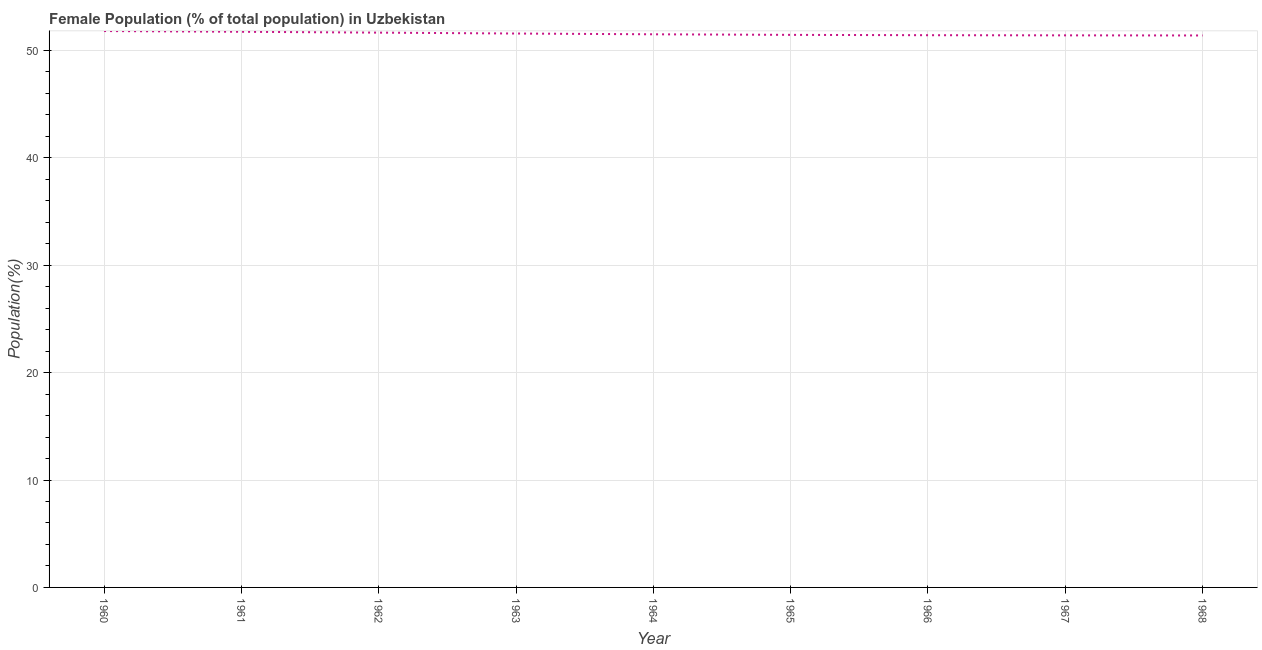What is the female population in 1961?
Your response must be concise. 51.73. Across all years, what is the maximum female population?
Ensure brevity in your answer.  51.79. Across all years, what is the minimum female population?
Keep it short and to the point. 51.38. In which year was the female population minimum?
Provide a succinct answer. 1968. What is the sum of the female population?
Provide a short and direct response. 463.84. What is the difference between the female population in 1967 and 1968?
Provide a short and direct response. 0.01. What is the average female population per year?
Your answer should be compact. 51.54. What is the median female population?
Ensure brevity in your answer.  51.49. In how many years, is the female population greater than 28 %?
Provide a succinct answer. 9. What is the ratio of the female population in 1964 to that in 1965?
Offer a very short reply. 1. Is the female population in 1960 less than that in 1961?
Give a very brief answer. No. Is the difference between the female population in 1965 and 1968 greater than the difference between any two years?
Keep it short and to the point. No. What is the difference between the highest and the second highest female population?
Keep it short and to the point. 0.07. Is the sum of the female population in 1963 and 1966 greater than the maximum female population across all years?
Keep it short and to the point. Yes. What is the difference between the highest and the lowest female population?
Provide a short and direct response. 0.41. In how many years, is the female population greater than the average female population taken over all years?
Provide a succinct answer. 4. Does the female population monotonically increase over the years?
Ensure brevity in your answer.  No. How many lines are there?
Keep it short and to the point. 1. What is the difference between two consecutive major ticks on the Y-axis?
Give a very brief answer. 10. Are the values on the major ticks of Y-axis written in scientific E-notation?
Ensure brevity in your answer.  No. Does the graph contain any zero values?
Give a very brief answer. No. Does the graph contain grids?
Your response must be concise. Yes. What is the title of the graph?
Keep it short and to the point. Female Population (% of total population) in Uzbekistan. What is the label or title of the Y-axis?
Offer a very short reply. Population(%). What is the Population(%) in 1960?
Make the answer very short. 51.79. What is the Population(%) of 1961?
Ensure brevity in your answer.  51.73. What is the Population(%) of 1962?
Your answer should be compact. 51.65. What is the Population(%) in 1963?
Your answer should be compact. 51.56. What is the Population(%) of 1964?
Make the answer very short. 51.49. What is the Population(%) in 1965?
Make the answer very short. 51.44. What is the Population(%) in 1966?
Provide a succinct answer. 51.41. What is the Population(%) in 1967?
Give a very brief answer. 51.39. What is the Population(%) in 1968?
Provide a short and direct response. 51.38. What is the difference between the Population(%) in 1960 and 1961?
Your response must be concise. 0.07. What is the difference between the Population(%) in 1960 and 1962?
Ensure brevity in your answer.  0.15. What is the difference between the Population(%) in 1960 and 1963?
Your answer should be very brief. 0.23. What is the difference between the Population(%) in 1960 and 1964?
Your answer should be very brief. 0.3. What is the difference between the Population(%) in 1960 and 1965?
Make the answer very short. 0.36. What is the difference between the Population(%) in 1960 and 1966?
Keep it short and to the point. 0.39. What is the difference between the Population(%) in 1960 and 1967?
Keep it short and to the point. 0.4. What is the difference between the Population(%) in 1960 and 1968?
Provide a succinct answer. 0.41. What is the difference between the Population(%) in 1961 and 1962?
Ensure brevity in your answer.  0.08. What is the difference between the Population(%) in 1961 and 1963?
Your answer should be compact. 0.16. What is the difference between the Population(%) in 1961 and 1964?
Give a very brief answer. 0.23. What is the difference between the Population(%) in 1961 and 1965?
Ensure brevity in your answer.  0.29. What is the difference between the Population(%) in 1961 and 1966?
Make the answer very short. 0.32. What is the difference between the Population(%) in 1961 and 1967?
Give a very brief answer. 0.33. What is the difference between the Population(%) in 1961 and 1968?
Your response must be concise. 0.34. What is the difference between the Population(%) in 1962 and 1963?
Your answer should be very brief. 0.08. What is the difference between the Population(%) in 1962 and 1964?
Keep it short and to the point. 0.15. What is the difference between the Population(%) in 1962 and 1965?
Provide a succinct answer. 0.21. What is the difference between the Population(%) in 1962 and 1966?
Your answer should be compact. 0.24. What is the difference between the Population(%) in 1962 and 1967?
Offer a very short reply. 0.25. What is the difference between the Population(%) in 1962 and 1968?
Make the answer very short. 0.26. What is the difference between the Population(%) in 1963 and 1964?
Offer a very short reply. 0.07. What is the difference between the Population(%) in 1963 and 1965?
Ensure brevity in your answer.  0.12. What is the difference between the Population(%) in 1963 and 1966?
Offer a terse response. 0.16. What is the difference between the Population(%) in 1963 and 1967?
Keep it short and to the point. 0.17. What is the difference between the Population(%) in 1963 and 1968?
Make the answer very short. 0.18. What is the difference between the Population(%) in 1964 and 1965?
Make the answer very short. 0.05. What is the difference between the Population(%) in 1964 and 1966?
Your answer should be very brief. 0.08. What is the difference between the Population(%) in 1964 and 1967?
Keep it short and to the point. 0.1. What is the difference between the Population(%) in 1964 and 1968?
Offer a terse response. 0.11. What is the difference between the Population(%) in 1965 and 1966?
Give a very brief answer. 0.03. What is the difference between the Population(%) in 1965 and 1967?
Your answer should be very brief. 0.04. What is the difference between the Population(%) in 1965 and 1968?
Offer a very short reply. 0.06. What is the difference between the Population(%) in 1966 and 1967?
Give a very brief answer. 0.01. What is the difference between the Population(%) in 1966 and 1968?
Keep it short and to the point. 0.02. What is the difference between the Population(%) in 1967 and 1968?
Make the answer very short. 0.01. What is the ratio of the Population(%) in 1960 to that in 1961?
Provide a short and direct response. 1. What is the ratio of the Population(%) in 1960 to that in 1963?
Give a very brief answer. 1. What is the ratio of the Population(%) in 1960 to that in 1966?
Offer a very short reply. 1.01. What is the ratio of the Population(%) in 1960 to that in 1967?
Provide a succinct answer. 1.01. What is the ratio of the Population(%) in 1960 to that in 1968?
Keep it short and to the point. 1.01. What is the ratio of the Population(%) in 1961 to that in 1963?
Offer a terse response. 1. What is the ratio of the Population(%) in 1961 to that in 1964?
Make the answer very short. 1. What is the ratio of the Population(%) in 1961 to that in 1965?
Keep it short and to the point. 1.01. What is the ratio of the Population(%) in 1961 to that in 1966?
Your response must be concise. 1.01. What is the ratio of the Population(%) in 1963 to that in 1964?
Make the answer very short. 1. What is the ratio of the Population(%) in 1963 to that in 1965?
Provide a succinct answer. 1. What is the ratio of the Population(%) in 1963 to that in 1966?
Your answer should be compact. 1. What is the ratio of the Population(%) in 1963 to that in 1968?
Give a very brief answer. 1. What is the ratio of the Population(%) in 1964 to that in 1965?
Give a very brief answer. 1. What is the ratio of the Population(%) in 1964 to that in 1966?
Your answer should be very brief. 1. What is the ratio of the Population(%) in 1964 to that in 1968?
Offer a terse response. 1. What is the ratio of the Population(%) in 1965 to that in 1966?
Your answer should be compact. 1. What is the ratio of the Population(%) in 1965 to that in 1967?
Provide a succinct answer. 1. What is the ratio of the Population(%) in 1966 to that in 1967?
Your response must be concise. 1. What is the ratio of the Population(%) in 1966 to that in 1968?
Your answer should be compact. 1. 